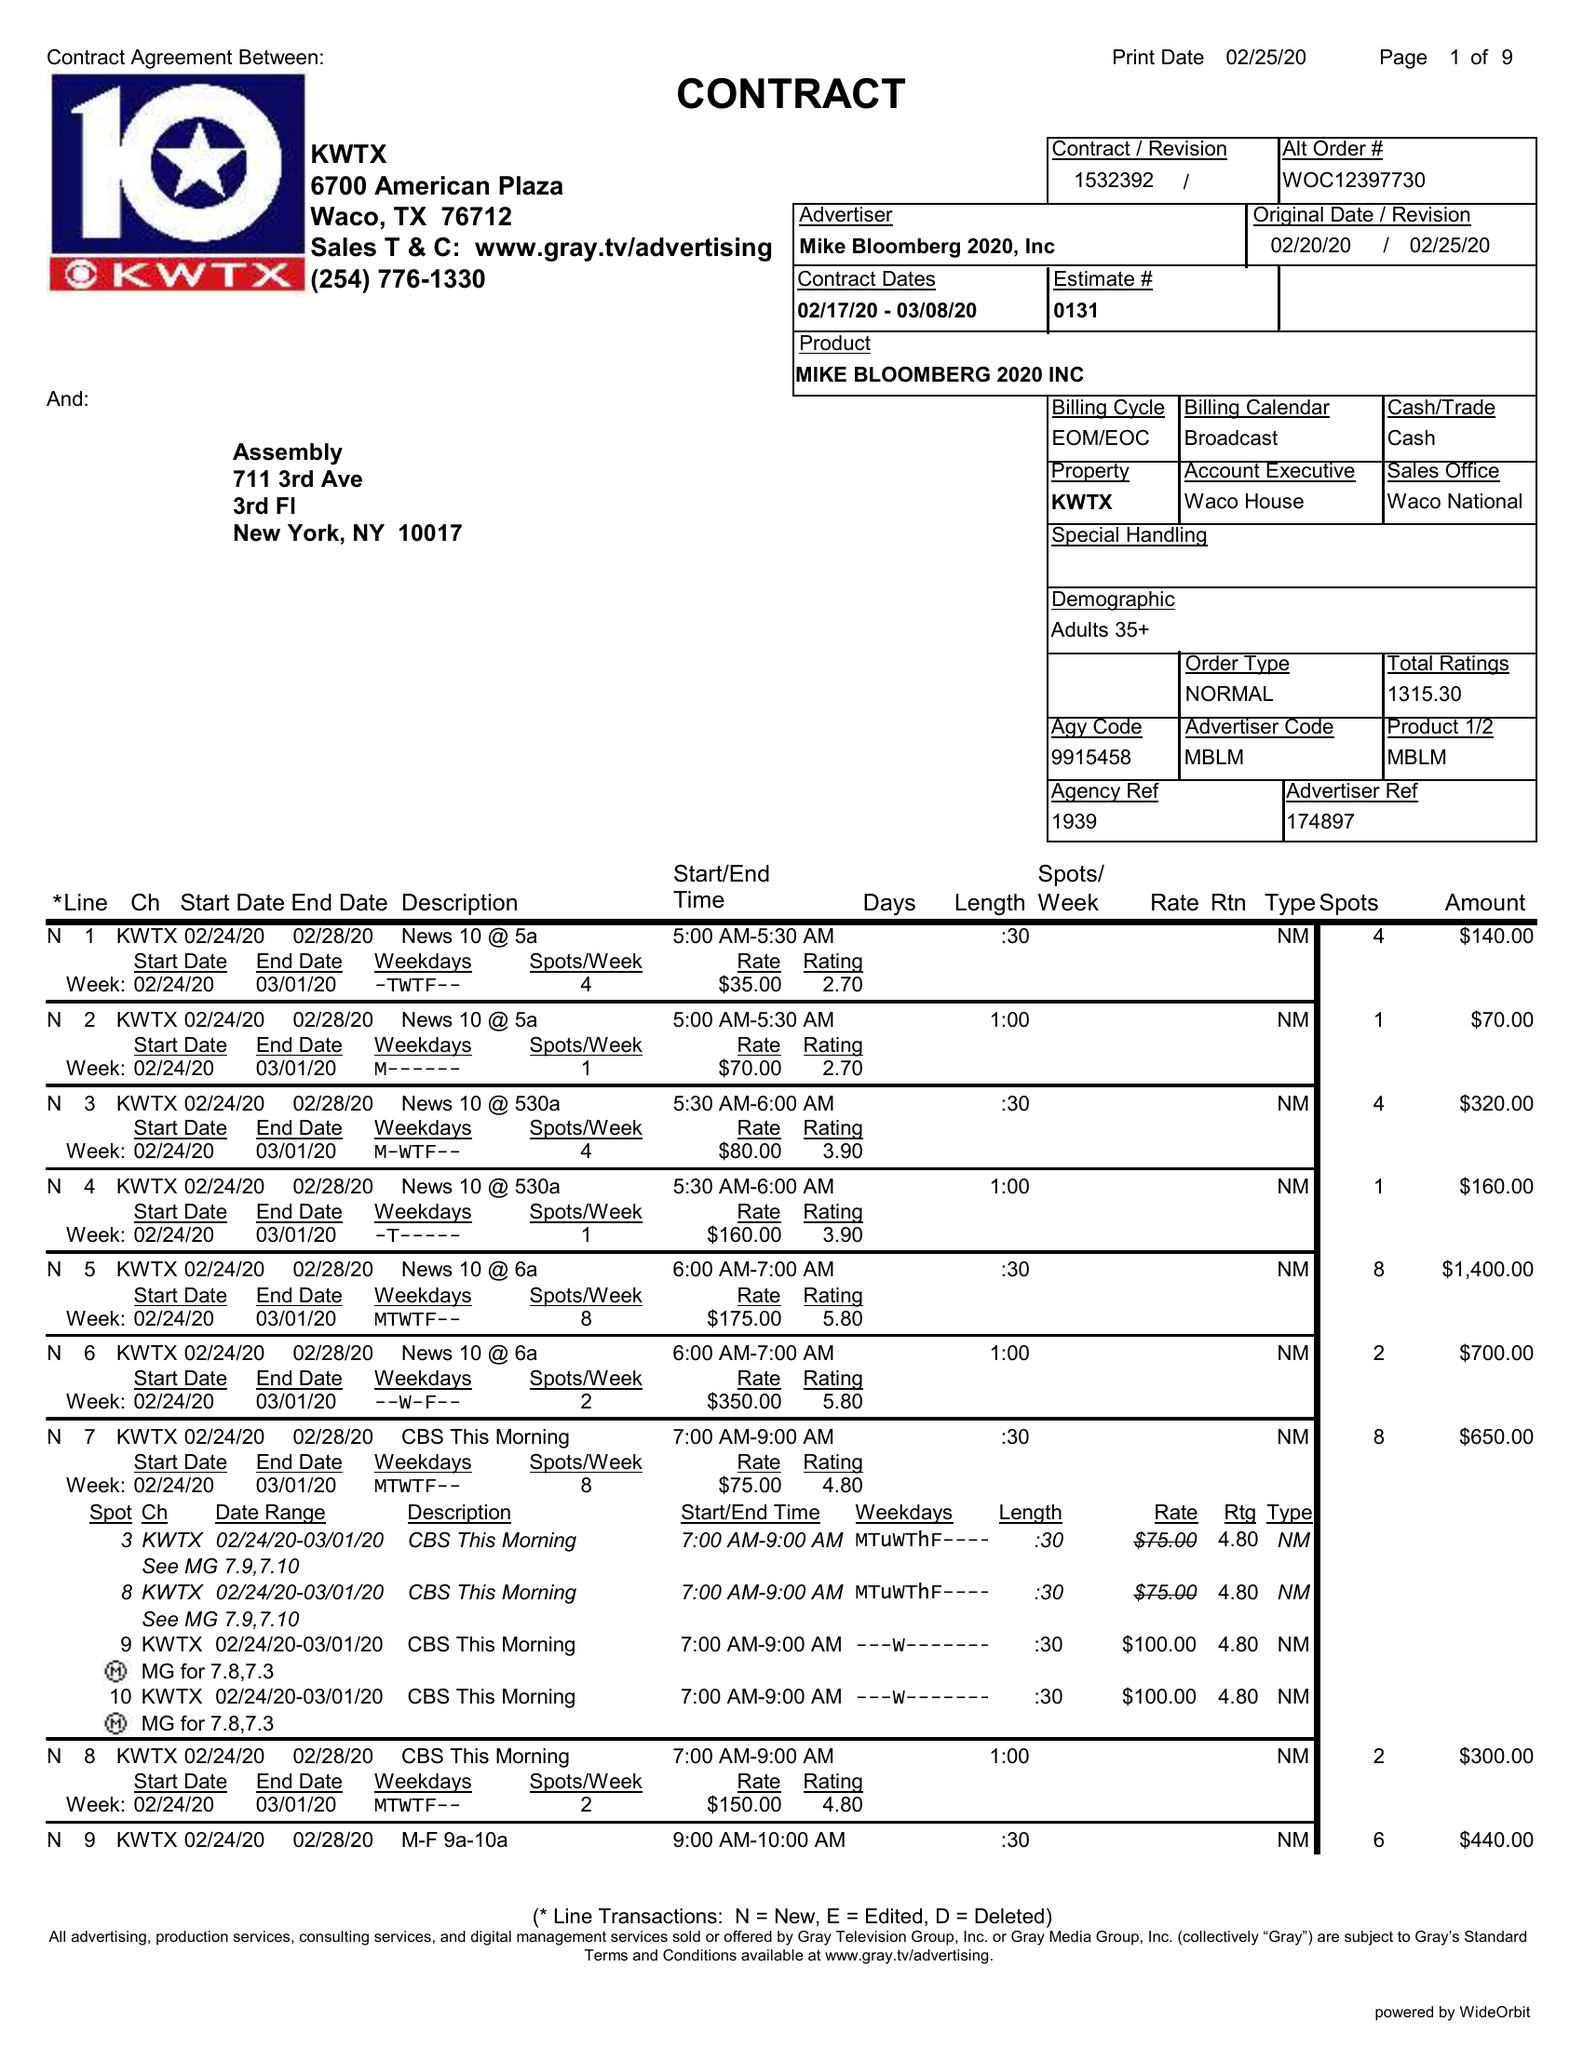What is the value for the contract_num?
Answer the question using a single word or phrase. 1532392 